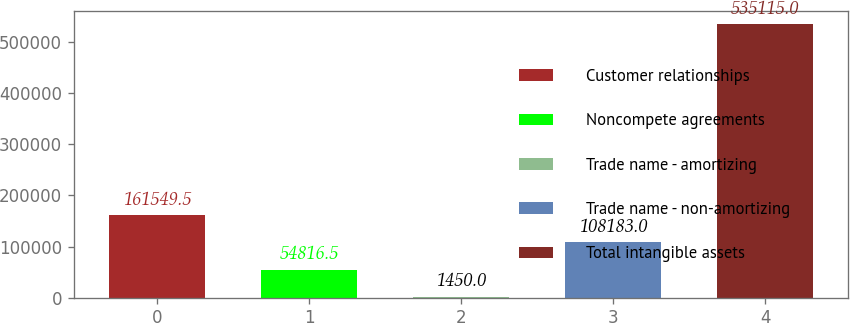Convert chart to OTSL. <chart><loc_0><loc_0><loc_500><loc_500><bar_chart><fcel>Customer relationships<fcel>Noncompete agreements<fcel>Trade name - amortizing<fcel>Trade name - non-amortizing<fcel>Total intangible assets<nl><fcel>161550<fcel>54816.5<fcel>1450<fcel>108183<fcel>535115<nl></chart> 